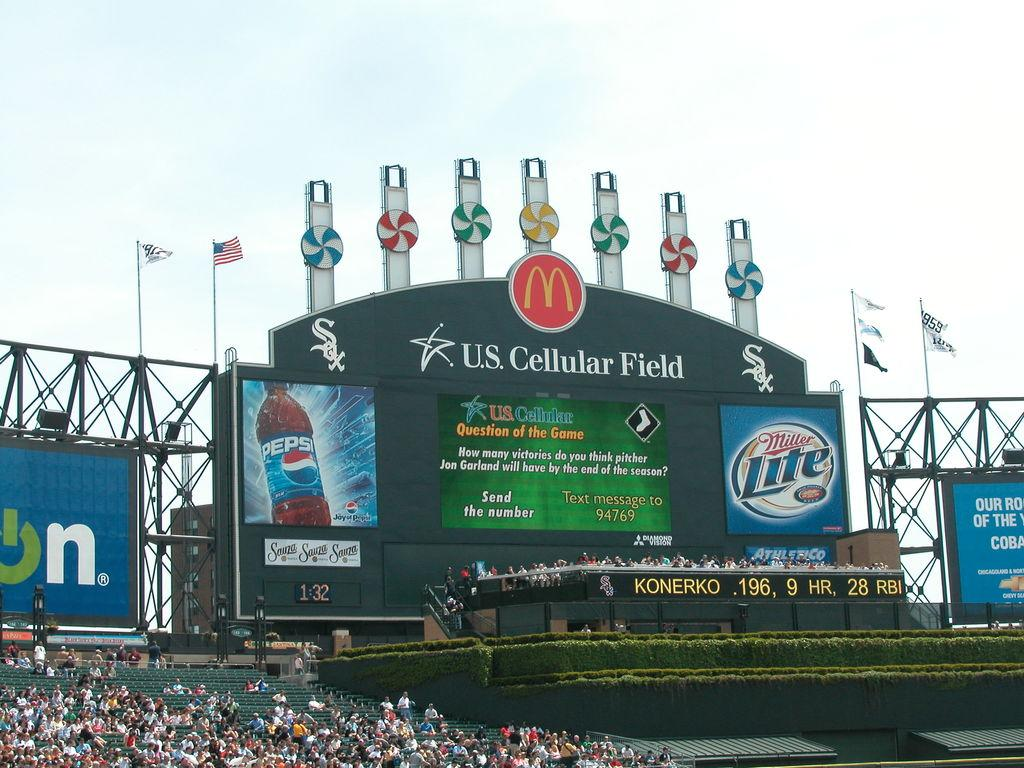<image>
Summarize the visual content of the image. Fans at the U.S. Cellular Field are gathered in the stands. 